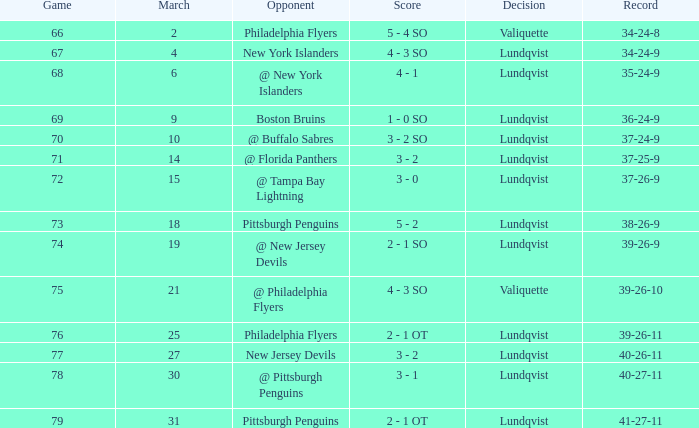When playing against the new york islanders and the march exceeded 2, which game had a score lower than 69? 4 - 3 SO. 